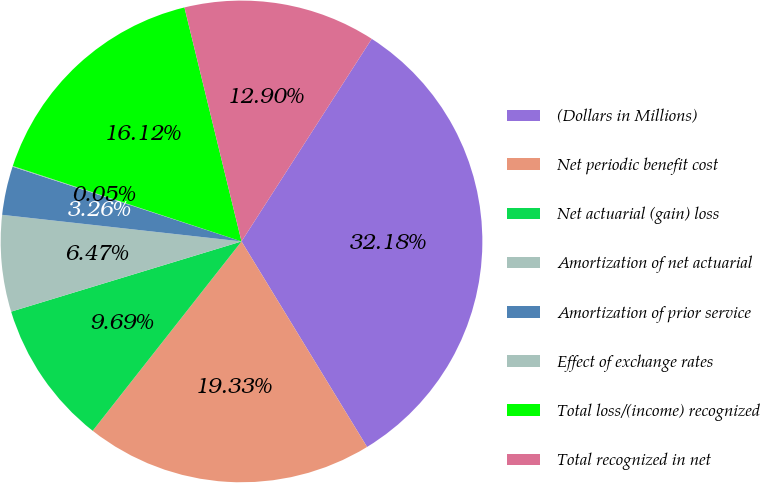<chart> <loc_0><loc_0><loc_500><loc_500><pie_chart><fcel>(Dollars in Millions)<fcel>Net periodic benefit cost<fcel>Net actuarial (gain) loss<fcel>Amortization of net actuarial<fcel>Amortization of prior service<fcel>Effect of exchange rates<fcel>Total loss/(income) recognized<fcel>Total recognized in net<nl><fcel>32.18%<fcel>19.33%<fcel>9.69%<fcel>6.47%<fcel>3.26%<fcel>0.05%<fcel>16.12%<fcel>12.9%<nl></chart> 